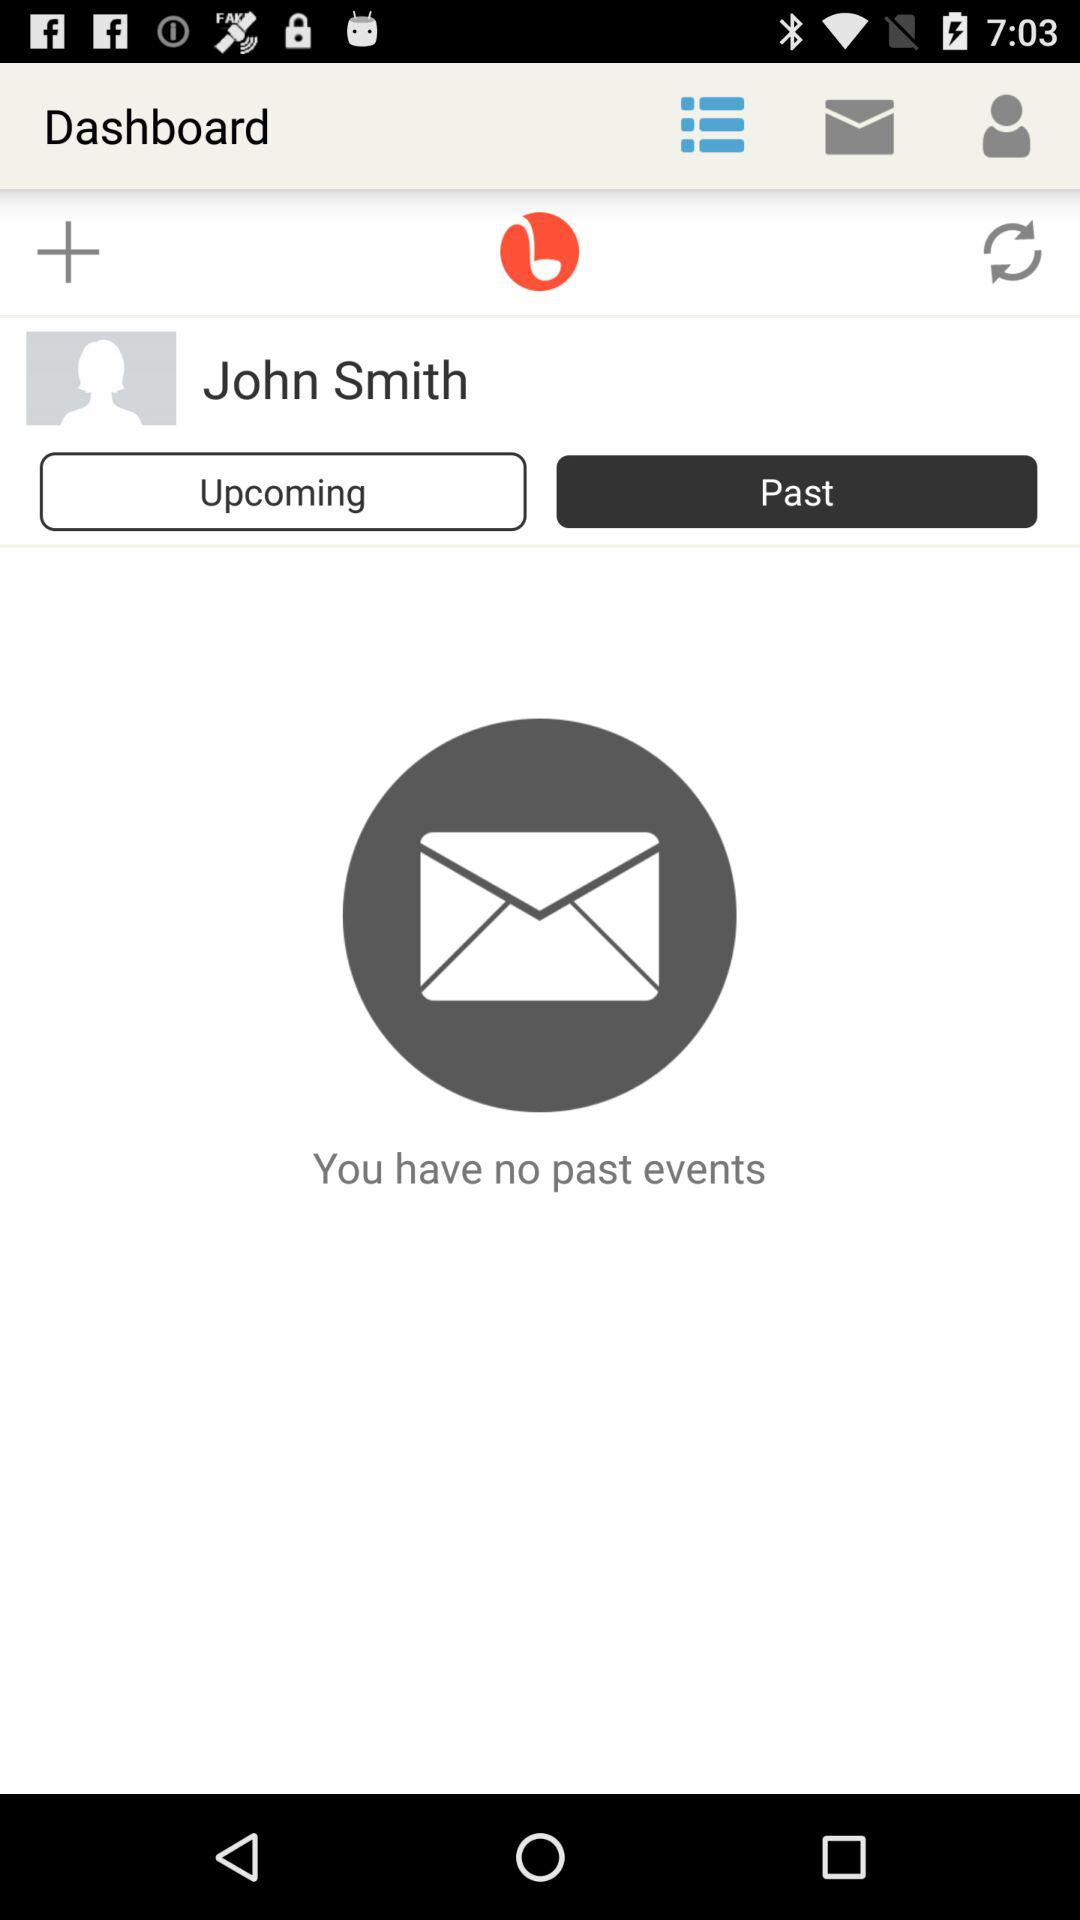What is the user profile name? The user profile name is John Smith. 